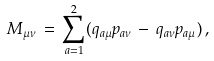<formula> <loc_0><loc_0><loc_500><loc_500>M _ { \mu \nu } \, = \, \sum _ { a = 1 } ^ { 2 } ( q _ { a \mu } p _ { a \nu } \, - \, q _ { a \nu } p _ { a \mu } ) \, { , }</formula> 